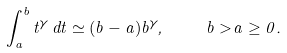<formula> <loc_0><loc_0><loc_500><loc_500>\int _ { a } ^ { b } t ^ { \gamma } \, d t \simeq ( b - a ) b ^ { \gamma } , \quad b > a \geq 0 .</formula> 